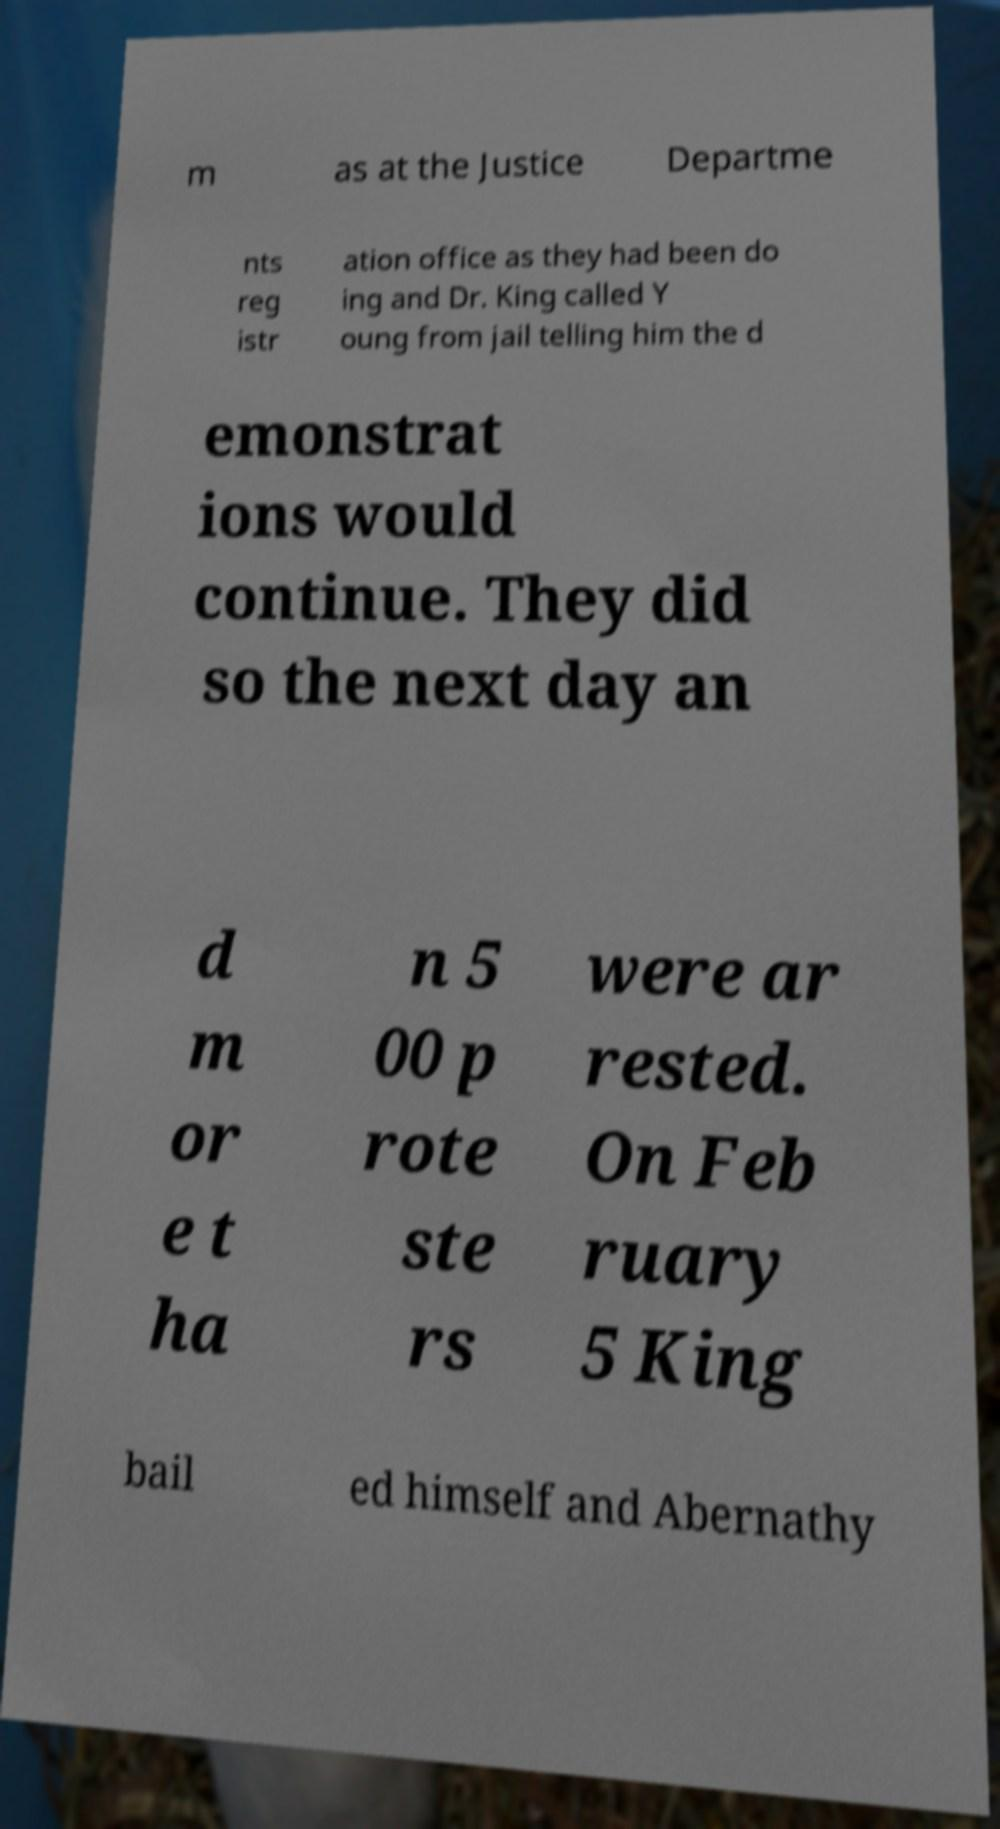For documentation purposes, I need the text within this image transcribed. Could you provide that? m as at the Justice Departme nts reg istr ation office as they had been do ing and Dr. King called Y oung from jail telling him the d emonstrat ions would continue. They did so the next day an d m or e t ha n 5 00 p rote ste rs were ar rested. On Feb ruary 5 King bail ed himself and Abernathy 